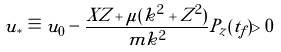Convert formula to latex. <formula><loc_0><loc_0><loc_500><loc_500>u _ { * } \equiv u _ { 0 } - \frac { X Z + \mu ( k ^ { 2 } + Z ^ { 2 } ) } { m k ^ { 2 } } P _ { z } ( t _ { f } ) > 0</formula> 